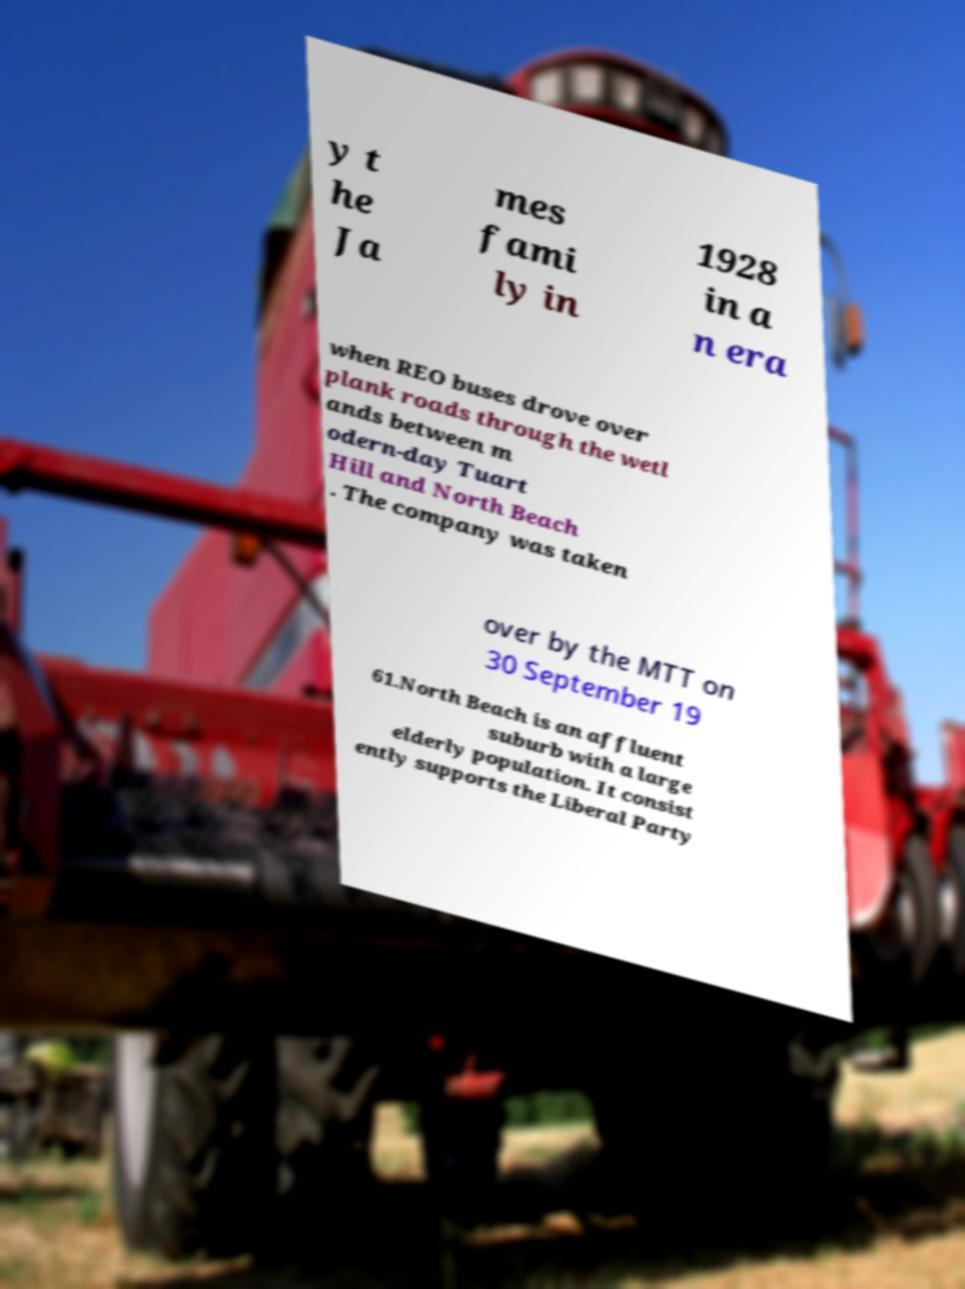For documentation purposes, I need the text within this image transcribed. Could you provide that? y t he Ja mes fami ly in 1928 in a n era when REO buses drove over plank roads through the wetl ands between m odern-day Tuart Hill and North Beach . The company was taken over by the MTT on 30 September 19 61.North Beach is an affluent suburb with a large elderly population. It consist ently supports the Liberal Party 